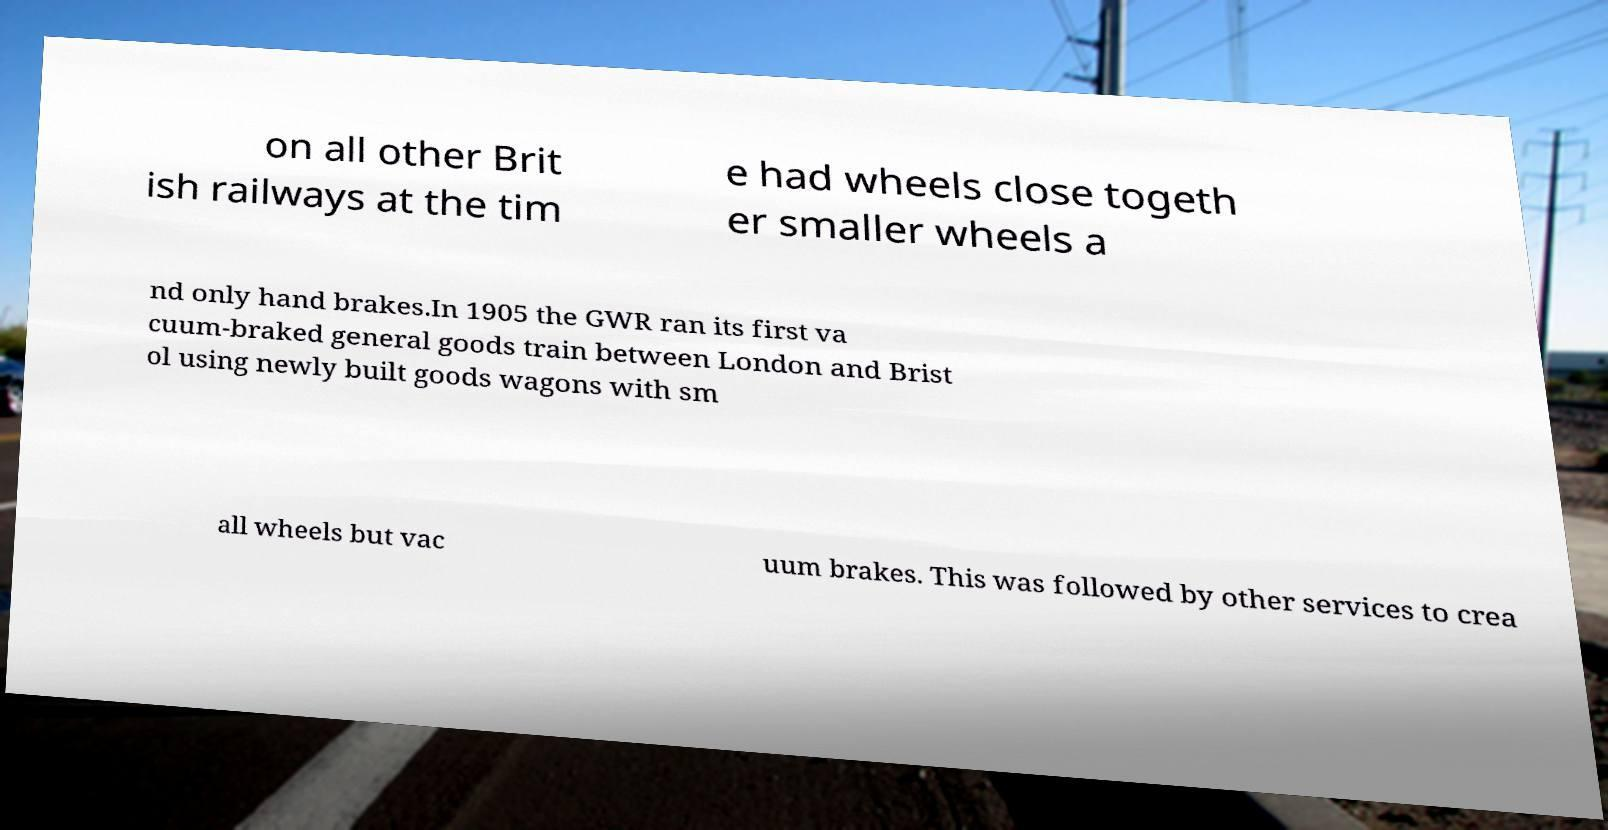Can you read and provide the text displayed in the image?This photo seems to have some interesting text. Can you extract and type it out for me? on all other Brit ish railways at the tim e had wheels close togeth er smaller wheels a nd only hand brakes.In 1905 the GWR ran its first va cuum-braked general goods train between London and Brist ol using newly built goods wagons with sm all wheels but vac uum brakes. This was followed by other services to crea 